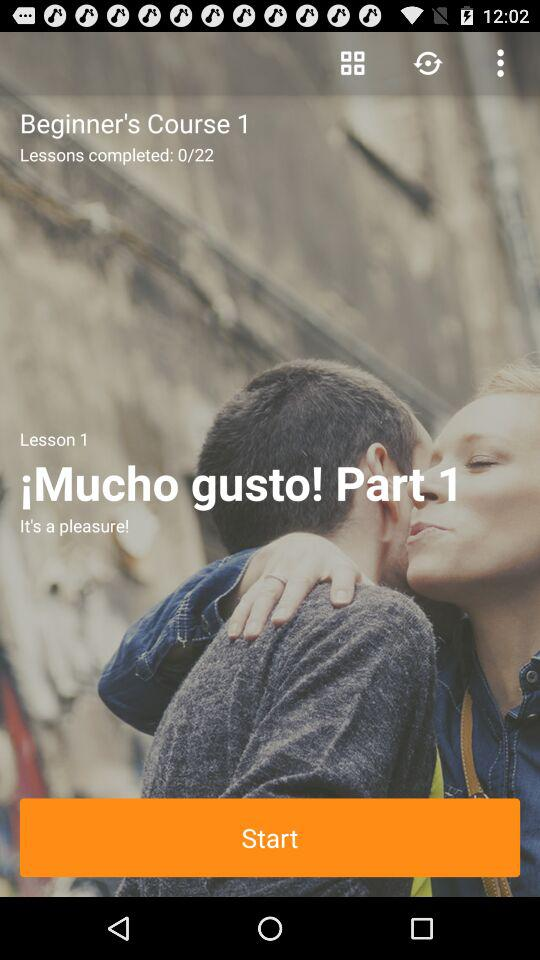How many lessons are there in total?
Answer the question using a single word or phrase. 22 